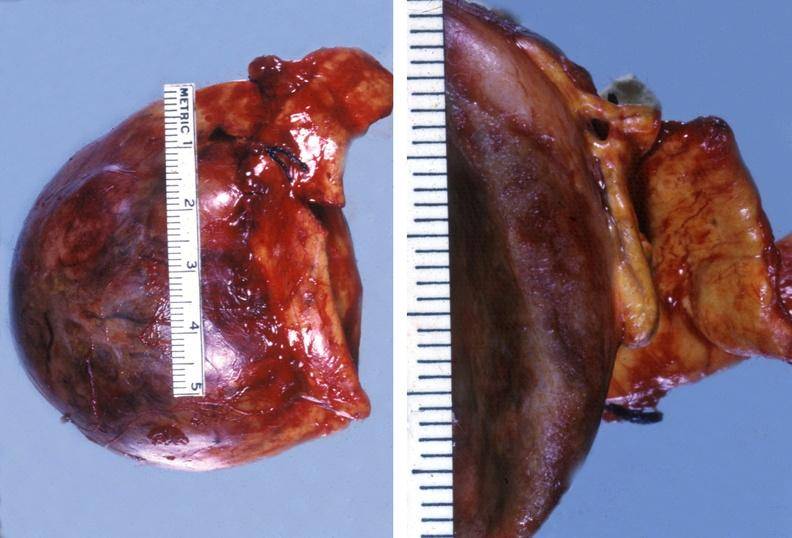does this image show adrenal phaeochromocytoma?
Answer the question using a single word or phrase. Yes 